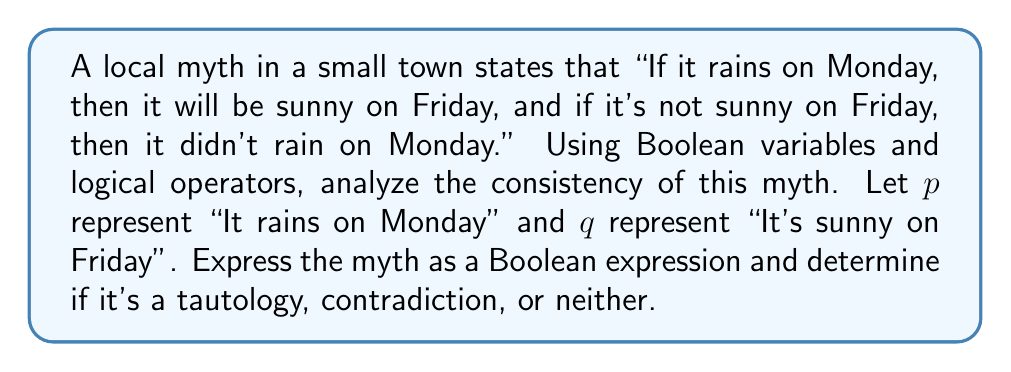Help me with this question. Let's approach this step-by-step:

1) First, let's translate the myth into a Boolean expression:
   Part 1: "If it rains on Monday, then it will be sunny on Friday"
   This translates to: $p \rightarrow q$
   
   Part 2: "If it's not sunny on Friday, then it didn't rain on Monday"
   This translates to: $\neg q \rightarrow \neg p$

2) The entire myth is the conjunction of these two parts:
   $(p \rightarrow q) \land (\neg q \rightarrow \neg p)$

3) To analyze if this is a tautology, contradiction, or neither, we need to construct a truth table:

   $p$ | $q$ | $p \rightarrow q$ | $\neg q \rightarrow \neg p$ | $(p \rightarrow q) \land (\neg q \rightarrow \neg p)$
   ----+-----+------------------+---------------------------+----------------------------------------
   T   | T   |        T         |            T              |                   T
   T   | F   |        F         |            T              |                   F
   F   | T   |        T         |            F              |                   F
   F   | F   |        T         |            T              |                   T

4) From the truth table, we can see that the expression is true for some combinations of $p$ and $q$, and false for others.

5) This means the expression is neither a tautology (always true) nor a contradiction (always false).

6) In fact, this expression is logically equivalent to the biconditional $p \leftrightarrow q$, which means "It rains on Monday if and only if it's sunny on Friday".

7) This reveals that the local myth, while internally consistent, makes a very strong claim about the relationship between Monday's rain and Friday's sun, which is unlikely to be true in reality.
Answer: Neither tautology nor contradiction; equivalent to $p \leftrightarrow q$ 